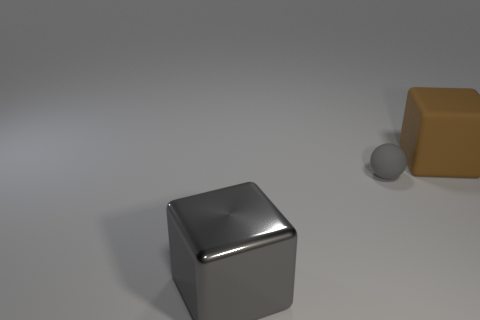The big thing that is in front of the brown block has what shape? cube 